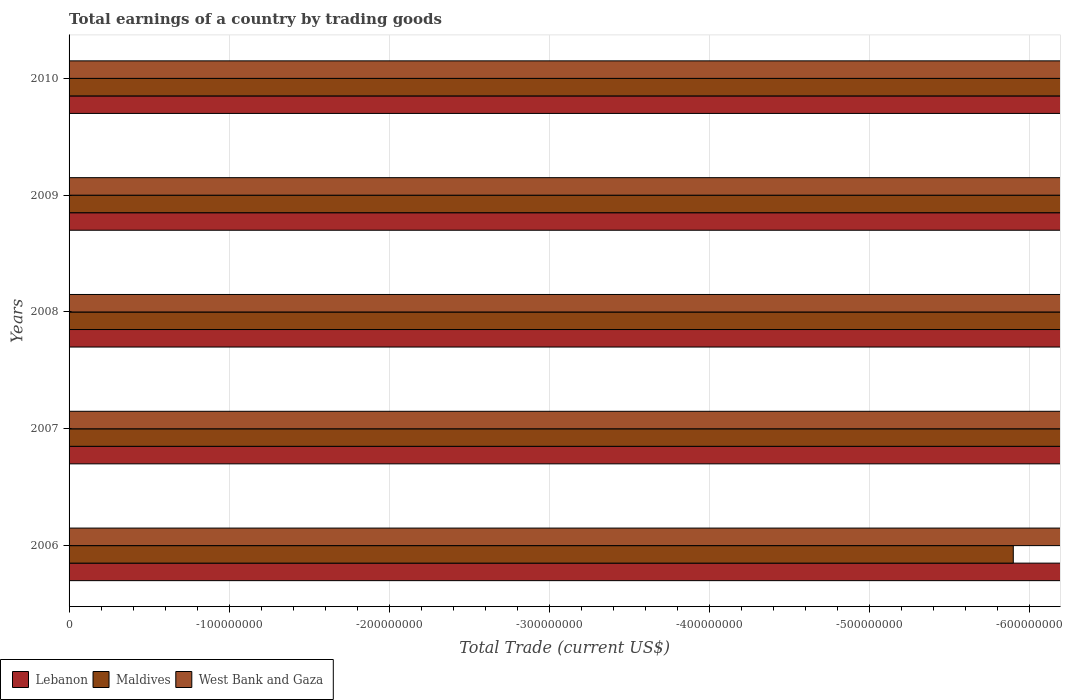How many different coloured bars are there?
Provide a succinct answer. 0. Are the number of bars per tick equal to the number of legend labels?
Offer a very short reply. No. How many bars are there on the 3rd tick from the top?
Keep it short and to the point. 0. How many bars are there on the 1st tick from the bottom?
Ensure brevity in your answer.  0. In how many cases, is the number of bars for a given year not equal to the number of legend labels?
Make the answer very short. 5. What is the total earnings in Maldives in 2010?
Your response must be concise. 0. What is the total total earnings in Maldives in the graph?
Your response must be concise. 0. What is the difference between the total earnings in Lebanon in 2010 and the total earnings in Maldives in 2009?
Your answer should be very brief. 0. What is the average total earnings in West Bank and Gaza per year?
Offer a very short reply. 0. In how many years, is the total earnings in Lebanon greater than -440000000 US$?
Offer a very short reply. 0. In how many years, is the total earnings in Lebanon greater than the average total earnings in Lebanon taken over all years?
Give a very brief answer. 0. Is it the case that in every year, the sum of the total earnings in Lebanon and total earnings in Maldives is greater than the total earnings in West Bank and Gaza?
Keep it short and to the point. No. Are all the bars in the graph horizontal?
Make the answer very short. Yes. What is the difference between two consecutive major ticks on the X-axis?
Your response must be concise. 1.00e+08. Are the values on the major ticks of X-axis written in scientific E-notation?
Your answer should be compact. No. How are the legend labels stacked?
Your answer should be very brief. Horizontal. What is the title of the graph?
Provide a short and direct response. Total earnings of a country by trading goods. What is the label or title of the X-axis?
Offer a very short reply. Total Trade (current US$). What is the Total Trade (current US$) of Lebanon in 2006?
Provide a succinct answer. 0. What is the Total Trade (current US$) in West Bank and Gaza in 2006?
Provide a succinct answer. 0. What is the Total Trade (current US$) of Lebanon in 2008?
Keep it short and to the point. 0. What is the Total Trade (current US$) of Lebanon in 2010?
Ensure brevity in your answer.  0. What is the Total Trade (current US$) in West Bank and Gaza in 2010?
Ensure brevity in your answer.  0. What is the average Total Trade (current US$) in Lebanon per year?
Ensure brevity in your answer.  0. What is the average Total Trade (current US$) of West Bank and Gaza per year?
Your answer should be compact. 0. 